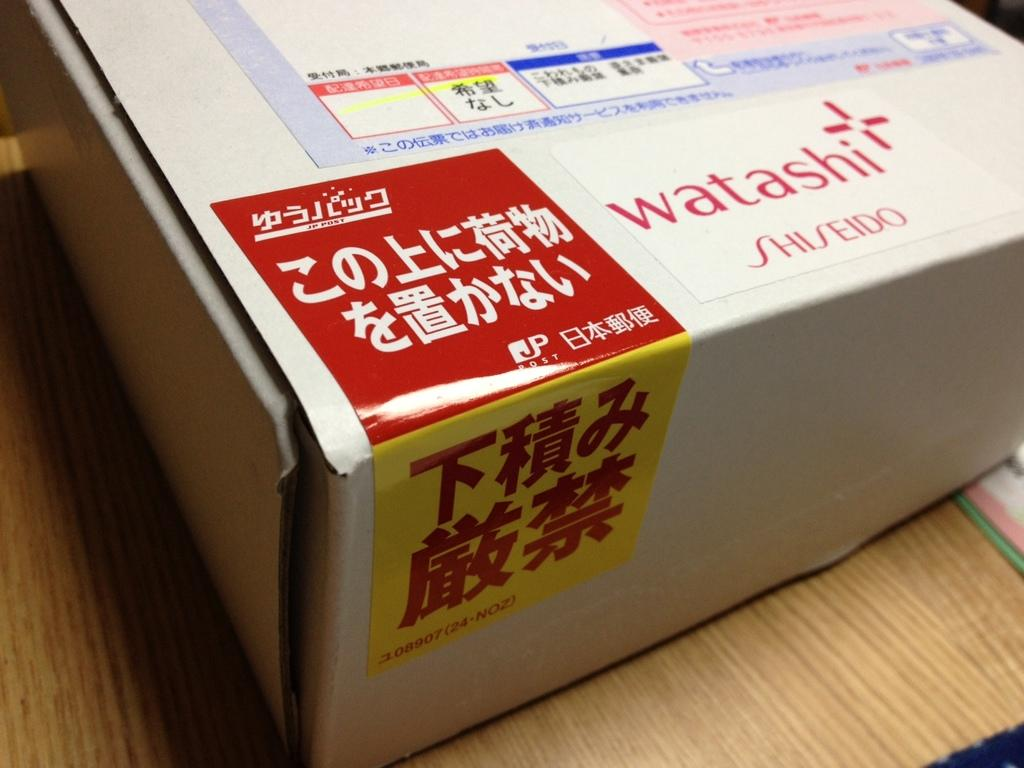<image>
Present a compact description of the photo's key features. A box of goods from Watashi Shiseido with the rest of the text written in Japanese. 